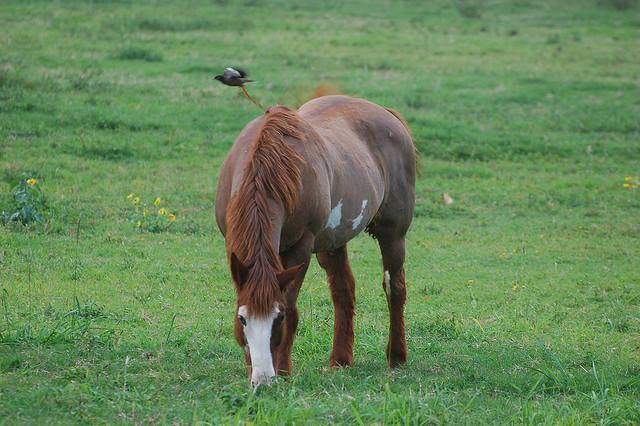What color are the legs of the horse?
Give a very brief answer. Brown. Is the horse standing?
Concise answer only. Yes. What kind of flower is growing in the grass?
Concise answer only. Dandelion. What color are the flowers?
Short answer required. Yellow. What color is the grass?
Keep it brief. Green. What is the horse eating?
Write a very short answer. Grass. 